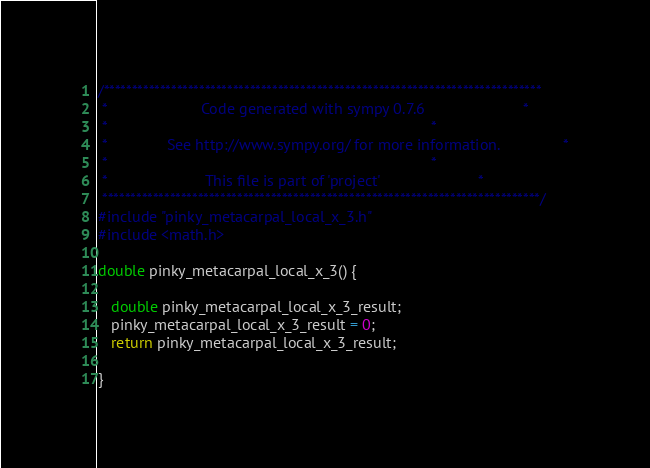Convert code to text. <code><loc_0><loc_0><loc_500><loc_500><_C_>/******************************************************************************
 *                      Code generated with sympy 0.7.6                       *
 *                                                                            *
 *              See http://www.sympy.org/ for more information.               *
 *                                                                            *
 *                       This file is part of 'project'                       *
 ******************************************************************************/
#include "pinky_metacarpal_local_x_3.h"
#include <math.h>

double pinky_metacarpal_local_x_3() {

   double pinky_metacarpal_local_x_3_result;
   pinky_metacarpal_local_x_3_result = 0;
   return pinky_metacarpal_local_x_3_result;

}
</code> 